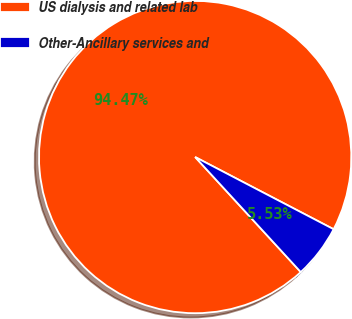<chart> <loc_0><loc_0><loc_500><loc_500><pie_chart><fcel>US dialysis and related lab<fcel>Other-Ancillary services and<nl><fcel>94.47%<fcel>5.53%<nl></chart> 